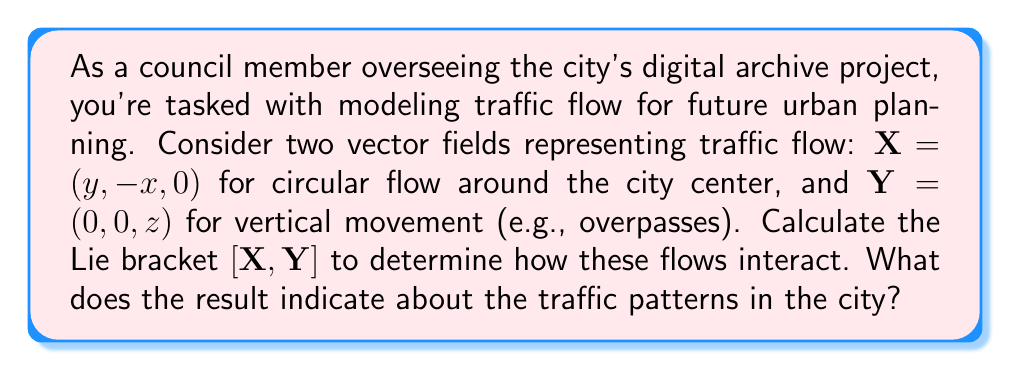Can you answer this question? To solve this problem, we need to follow these steps:

1) Recall the formula for the Lie bracket of two vector fields $X = (X_1, X_2, X_3)$ and $Y = (Y_1, Y_2, Y_3)$:

   $$[X, Y] = \left(\sum_{i=1}^3 X_i \frac{\partial Y_1}{\partial x_i} - Y_i \frac{\partial X_1}{\partial x_i}, \sum_{i=1}^3 X_i \frac{\partial Y_2}{\partial x_i} - Y_i \frac{\partial X_2}{\partial x_i}, \sum_{i=1}^3 X_i \frac{\partial Y_3}{\partial x_i} - Y_i \frac{\partial X_3}{\partial x_i}\right)$$

2) In our case:
   $X = (y, -x, 0)$ and $Y = (0, 0, z)$

3) Calculate the partial derivatives:
   $\frac{\partial Y_1}{\partial x_i} = \frac{\partial Y_2}{\partial x_i} = 0$ for all $i$
   $\frac{\partial Y_3}{\partial x} = \frac{\partial Y_3}{\partial y} = 0$, $\frac{\partial Y_3}{\partial z} = 1$
   $\frac{\partial X_1}{\partial x} = 0$, $\frac{\partial X_1}{\partial y} = 1$, $\frac{\partial X_1}{\partial z} = 0$
   $\frac{\partial X_2}{\partial x} = -1$, $\frac{\partial X_2}{\partial y} = \frac{\partial X_2}{\partial z} = 0$
   $\frac{\partial X_3}{\partial x_i} = 0$ for all $i$

4) Now, let's compute each component of $[X, Y]$:

   First component:
   $$X_1 \frac{\partial Y_1}{\partial x} + X_2 \frac{\partial Y_1}{\partial y} + X_3 \frac{\partial Y_1}{\partial z} - Y_1 \frac{\partial X_1}{\partial x} - Y_2 \frac{\partial X_1}{\partial y} - Y_3 \frac{\partial X_1}{\partial z} = 0 - 0 - z = -z$$

   Second component:
   $$X_1 \frac{\partial Y_2}{\partial x} + X_2 \frac{\partial Y_2}{\partial y} + X_3 \frac{\partial Y_2}{\partial z} - Y_1 \frac{\partial X_2}{\partial x} - Y_2 \frac{\partial X_2}{\partial y} - Y_3 \frac{\partial X_2}{\partial z} = 0 - 0 - 0 = 0$$

   Third component:
   $$X_1 \frac{\partial Y_3}{\partial x} + X_2 \frac{\partial Y_3}{\partial y} + X_3 \frac{\partial Y_3}{\partial z} - Y_1 \frac{\partial X_3}{\partial x} - Y_2 \frac{\partial X_3}{\partial y} - Y_3 \frac{\partial X_3}{\partial z} = y \cdot 0 + (-x) \cdot 0 + 0 \cdot 1 - 0 = 0$$

5) Therefore, $[X, Y] = (-z, 0, 0)$

The result indicates that the interaction between the circular flow around the city center and the vertical movement creates a horizontal flow towards the city center, with magnitude proportional to the height. This suggests that traffic from overpasses tends to move towards the city center at ground level.
Answer: $[X, Y] = (-z, 0, 0)$, indicating a horizontal flow towards the city center with magnitude proportional to height. 